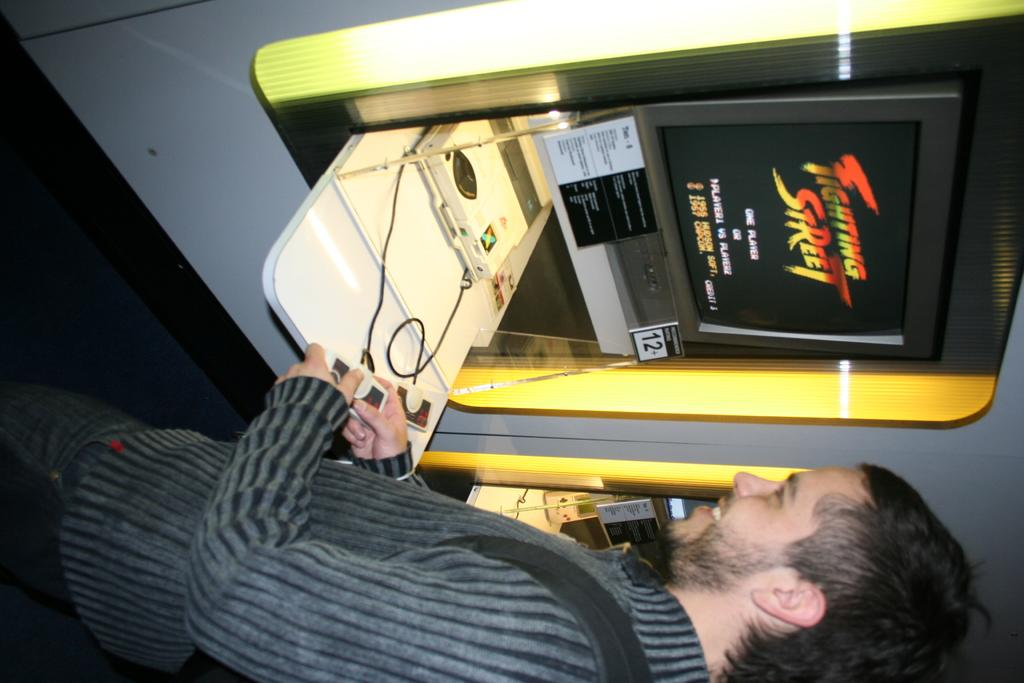What is the main subject of the image? There is a person standing in the image. What is the person holding in the image? The person is holding an object. Can you describe the object with a screen attached to it? There is a screen attached to an object in the image. What type of objects can be seen in the image besides the person and the object with a screen? There are boards and other objects present in the image. What type of error can be seen on the boards in the image? There is no mention of an error on the boards in the image; they are simply present as objects. Is there a cook visible in the image? There is no mention of a cook in the image; the main subject is a person standing. 